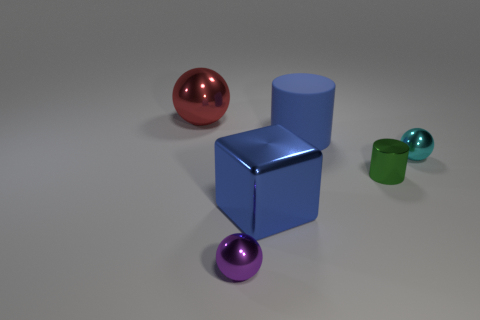What number of small things are in front of the tiny cyan object and to the right of the rubber thing?
Provide a short and direct response. 1. What is the material of the large blue cylinder?
Offer a very short reply. Rubber. Are there any small cylinders?
Offer a terse response. Yes. What is the color of the large metal thing that is right of the large ball?
Make the answer very short. Blue. What number of blue rubber cylinders are behind the tiny object to the left of the big object in front of the cyan thing?
Keep it short and to the point. 1. There is a thing that is both right of the blue cube and behind the tiny cyan ball; what is its material?
Ensure brevity in your answer.  Rubber. Are the purple sphere and the large thing left of the large blue metal block made of the same material?
Offer a terse response. Yes. Is the number of cylinders on the right side of the rubber thing greater than the number of large red shiny objects that are on the right side of the small green shiny object?
Keep it short and to the point. Yes. The large blue rubber object has what shape?
Make the answer very short. Cylinder. Is the material of the blue object that is behind the blue shiny block the same as the tiny sphere to the left of the blue cylinder?
Offer a very short reply. No. 